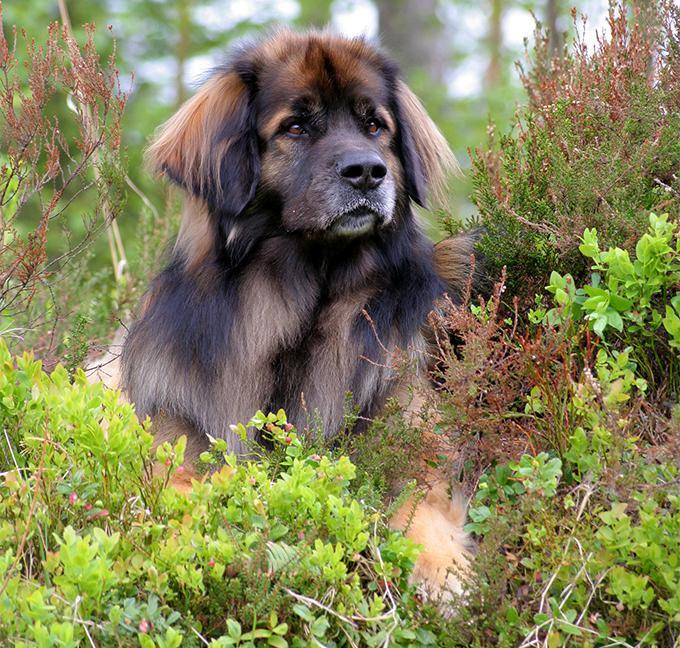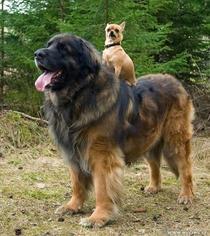The first image is the image on the left, the second image is the image on the right. Examine the images to the left and right. Is the description "There are two dogs in the image on the right." accurate? Answer yes or no. Yes. The first image is the image on the left, the second image is the image on the right. Evaluate the accuracy of this statement regarding the images: "One dog is positioned on the back of another dog.". Is it true? Answer yes or no. Yes. 